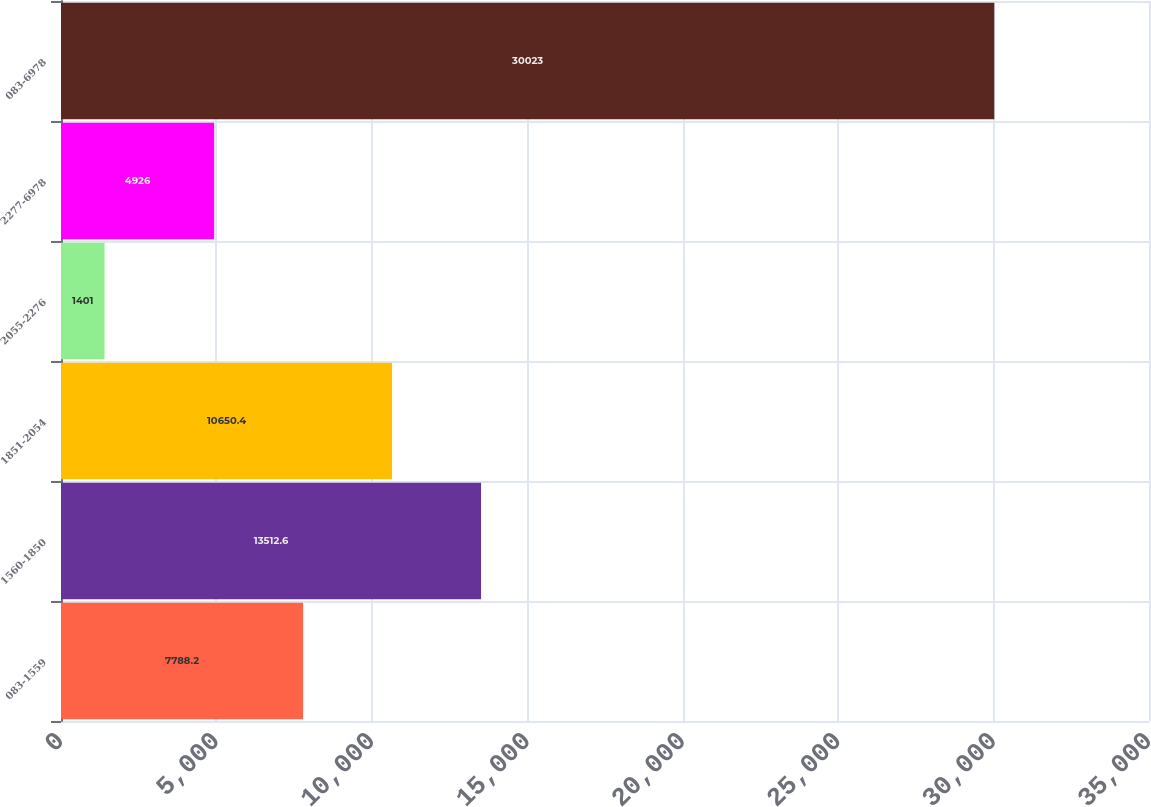Convert chart. <chart><loc_0><loc_0><loc_500><loc_500><bar_chart><fcel>083-1559<fcel>1560-1850<fcel>1851-2054<fcel>2055-2276<fcel>2277-6978<fcel>083-6978<nl><fcel>7788.2<fcel>13512.6<fcel>10650.4<fcel>1401<fcel>4926<fcel>30023<nl></chart> 